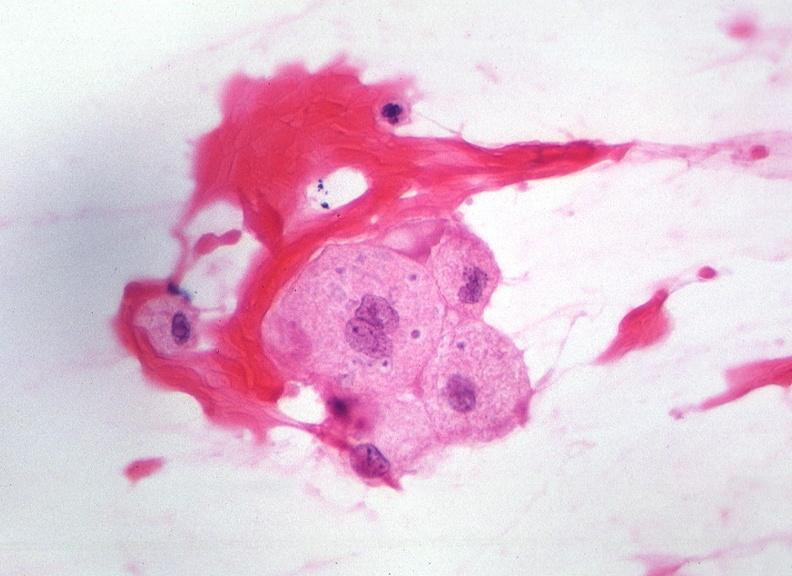s focal hemorrhagic infarction well shown present?
Answer the question using a single word or phrase. No 